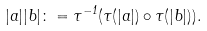<formula> <loc_0><loc_0><loc_500><loc_500>| a | | b | \colon = \tau ^ { - 1 } ( \tau ( | a | ) \circ \tau ( | b | ) ) .</formula> 